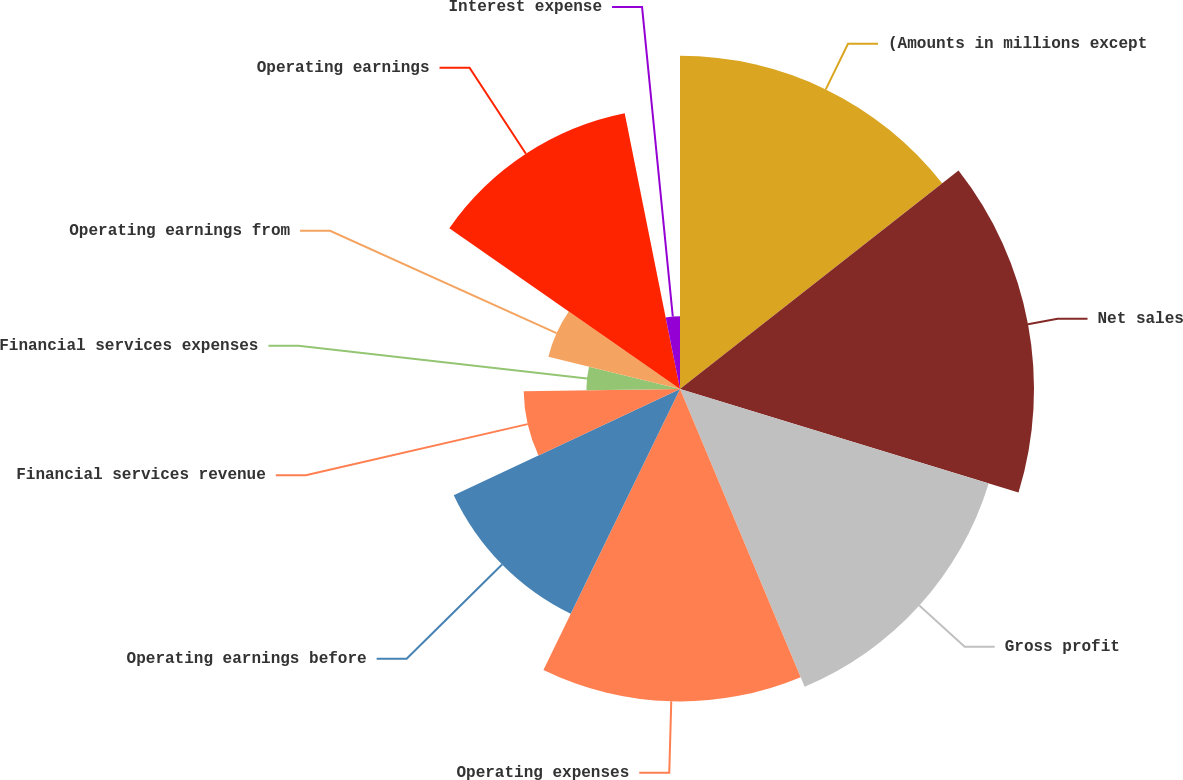<chart> <loc_0><loc_0><loc_500><loc_500><pie_chart><fcel>(Amounts in millions except<fcel>Net sales<fcel>Gross profit<fcel>Operating expenses<fcel>Operating earnings before<fcel>Financial services revenue<fcel>Financial services expenses<fcel>Operating earnings from<fcel>Operating earnings<fcel>Interest expense<nl><fcel>14.41%<fcel>15.31%<fcel>13.96%<fcel>13.51%<fcel>10.81%<fcel>6.76%<fcel>4.05%<fcel>5.86%<fcel>12.16%<fcel>3.15%<nl></chart> 